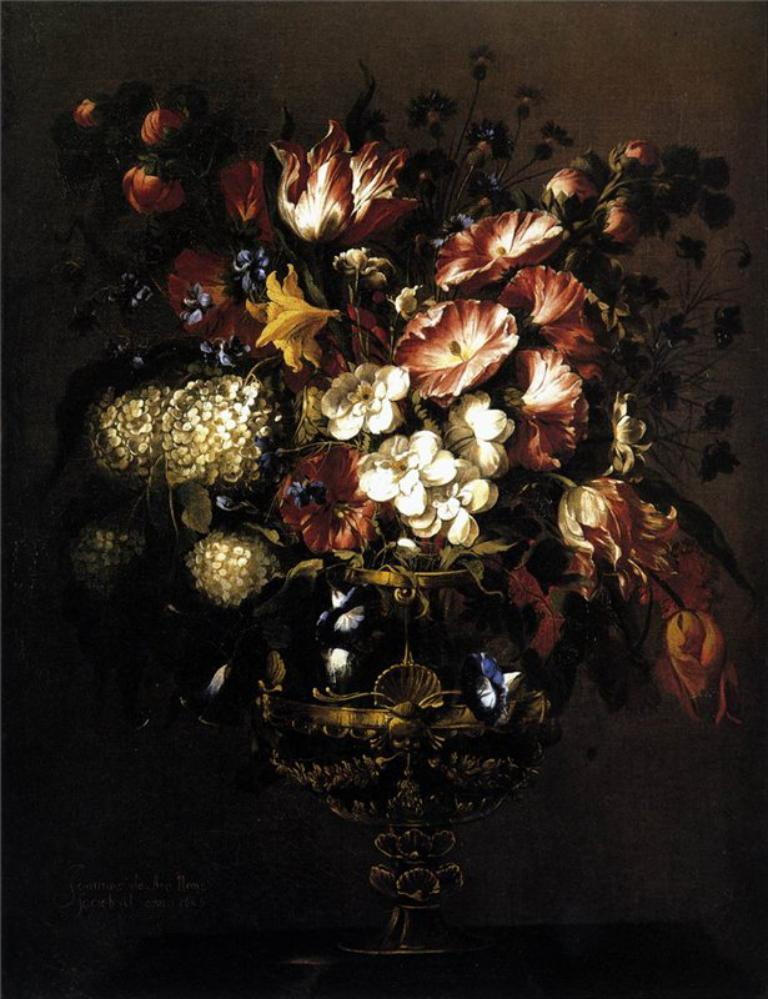What is the overall lighting condition in the image? The image is dark. What type of flora can be seen in the image? There are flowers in the image. How many kittens are playing with the letter in the image? There are no kittens or letters present in the image; it only features flowers in a dark setting. 